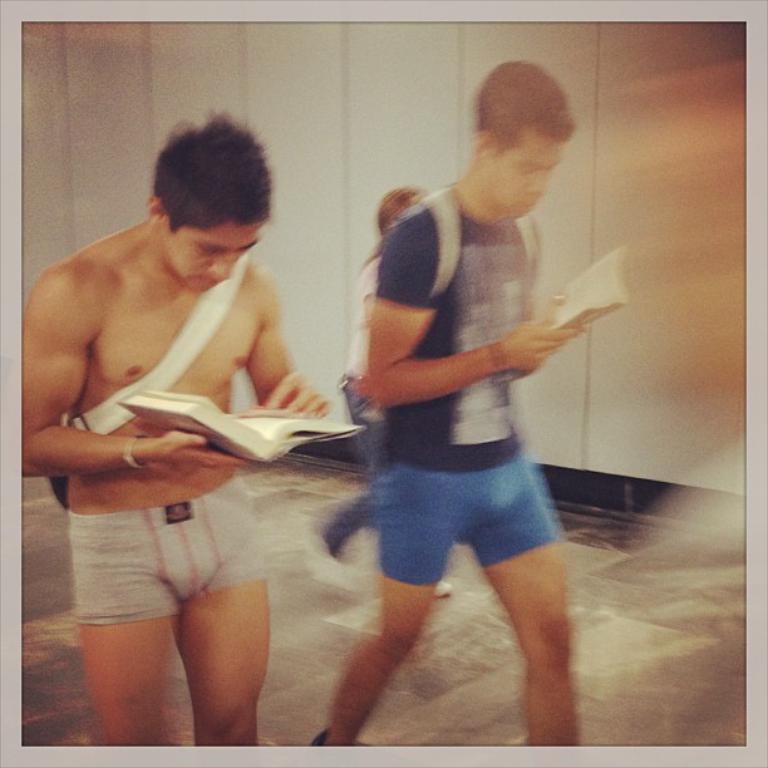How would you summarize this image in a sentence or two? In the image few people are walking and holding books. Behind them there is wall. 